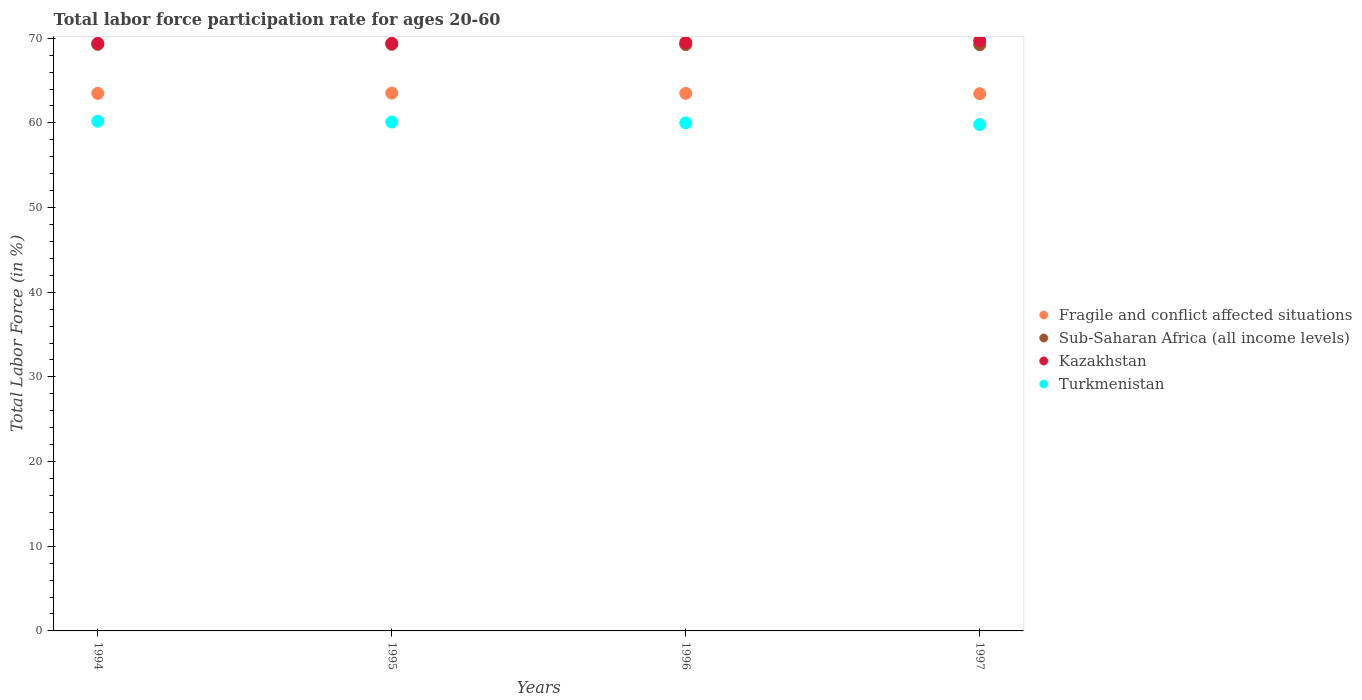How many different coloured dotlines are there?
Your answer should be very brief. 4. What is the labor force participation rate in Sub-Saharan Africa (all income levels) in 1995?
Offer a terse response. 69.28. Across all years, what is the maximum labor force participation rate in Sub-Saharan Africa (all income levels)?
Offer a terse response. 69.28. Across all years, what is the minimum labor force participation rate in Kazakhstan?
Offer a very short reply. 69.4. In which year was the labor force participation rate in Kazakhstan minimum?
Ensure brevity in your answer.  1994. What is the total labor force participation rate in Turkmenistan in the graph?
Your response must be concise. 240.1. What is the difference between the labor force participation rate in Sub-Saharan Africa (all income levels) in 1994 and that in 1997?
Ensure brevity in your answer.  0.04. What is the difference between the labor force participation rate in Fragile and conflict affected situations in 1994 and the labor force participation rate in Turkmenistan in 1997?
Keep it short and to the point. 3.69. What is the average labor force participation rate in Turkmenistan per year?
Make the answer very short. 60.02. In the year 1997, what is the difference between the labor force participation rate in Turkmenistan and labor force participation rate in Sub-Saharan Africa (all income levels)?
Your answer should be very brief. -9.43. Is the labor force participation rate in Turkmenistan in 1994 less than that in 1996?
Keep it short and to the point. No. Is the difference between the labor force participation rate in Turkmenistan in 1994 and 1996 greater than the difference between the labor force participation rate in Sub-Saharan Africa (all income levels) in 1994 and 1996?
Your response must be concise. Yes. What is the difference between the highest and the second highest labor force participation rate in Turkmenistan?
Your answer should be very brief. 0.1. What is the difference between the highest and the lowest labor force participation rate in Sub-Saharan Africa (all income levels)?
Your answer should be compact. 0.04. In how many years, is the labor force participation rate in Fragile and conflict affected situations greater than the average labor force participation rate in Fragile and conflict affected situations taken over all years?
Your answer should be compact. 3. Is the sum of the labor force participation rate in Sub-Saharan Africa (all income levels) in 1994 and 1996 greater than the maximum labor force participation rate in Fragile and conflict affected situations across all years?
Offer a very short reply. Yes. Is it the case that in every year, the sum of the labor force participation rate in Fragile and conflict affected situations and labor force participation rate in Sub-Saharan Africa (all income levels)  is greater than the labor force participation rate in Turkmenistan?
Your answer should be very brief. Yes. Does the labor force participation rate in Sub-Saharan Africa (all income levels) monotonically increase over the years?
Offer a very short reply. No. How many dotlines are there?
Provide a succinct answer. 4. Are the values on the major ticks of Y-axis written in scientific E-notation?
Provide a succinct answer. No. Does the graph contain any zero values?
Make the answer very short. No. Does the graph contain grids?
Provide a short and direct response. No. How many legend labels are there?
Make the answer very short. 4. What is the title of the graph?
Give a very brief answer. Total labor force participation rate for ages 20-60. What is the label or title of the X-axis?
Keep it short and to the point. Years. What is the Total Labor Force (in %) in Fragile and conflict affected situations in 1994?
Make the answer very short. 63.49. What is the Total Labor Force (in %) of Sub-Saharan Africa (all income levels) in 1994?
Give a very brief answer. 69.27. What is the Total Labor Force (in %) in Kazakhstan in 1994?
Offer a very short reply. 69.4. What is the Total Labor Force (in %) of Turkmenistan in 1994?
Provide a succinct answer. 60.2. What is the Total Labor Force (in %) in Fragile and conflict affected situations in 1995?
Give a very brief answer. 63.52. What is the Total Labor Force (in %) in Sub-Saharan Africa (all income levels) in 1995?
Provide a succinct answer. 69.28. What is the Total Labor Force (in %) in Kazakhstan in 1995?
Keep it short and to the point. 69.4. What is the Total Labor Force (in %) in Turkmenistan in 1995?
Make the answer very short. 60.1. What is the Total Labor Force (in %) in Fragile and conflict affected situations in 1996?
Your response must be concise. 63.49. What is the Total Labor Force (in %) in Sub-Saharan Africa (all income levels) in 1996?
Your answer should be very brief. 69.25. What is the Total Labor Force (in %) in Kazakhstan in 1996?
Offer a very short reply. 69.5. What is the Total Labor Force (in %) of Fragile and conflict affected situations in 1997?
Ensure brevity in your answer.  63.45. What is the Total Labor Force (in %) of Sub-Saharan Africa (all income levels) in 1997?
Offer a terse response. 69.23. What is the Total Labor Force (in %) of Kazakhstan in 1997?
Make the answer very short. 69.7. What is the Total Labor Force (in %) of Turkmenistan in 1997?
Provide a succinct answer. 59.8. Across all years, what is the maximum Total Labor Force (in %) of Fragile and conflict affected situations?
Your answer should be very brief. 63.52. Across all years, what is the maximum Total Labor Force (in %) of Sub-Saharan Africa (all income levels)?
Your answer should be compact. 69.28. Across all years, what is the maximum Total Labor Force (in %) of Kazakhstan?
Ensure brevity in your answer.  69.7. Across all years, what is the maximum Total Labor Force (in %) of Turkmenistan?
Make the answer very short. 60.2. Across all years, what is the minimum Total Labor Force (in %) in Fragile and conflict affected situations?
Ensure brevity in your answer.  63.45. Across all years, what is the minimum Total Labor Force (in %) in Sub-Saharan Africa (all income levels)?
Provide a short and direct response. 69.23. Across all years, what is the minimum Total Labor Force (in %) of Kazakhstan?
Your response must be concise. 69.4. Across all years, what is the minimum Total Labor Force (in %) in Turkmenistan?
Offer a terse response. 59.8. What is the total Total Labor Force (in %) in Fragile and conflict affected situations in the graph?
Your response must be concise. 253.95. What is the total Total Labor Force (in %) of Sub-Saharan Africa (all income levels) in the graph?
Offer a very short reply. 277.03. What is the total Total Labor Force (in %) of Kazakhstan in the graph?
Your answer should be compact. 278. What is the total Total Labor Force (in %) in Turkmenistan in the graph?
Offer a terse response. 240.1. What is the difference between the Total Labor Force (in %) of Fragile and conflict affected situations in 1994 and that in 1995?
Give a very brief answer. -0.03. What is the difference between the Total Labor Force (in %) of Sub-Saharan Africa (all income levels) in 1994 and that in 1995?
Keep it short and to the point. -0.01. What is the difference between the Total Labor Force (in %) in Fragile and conflict affected situations in 1994 and that in 1996?
Keep it short and to the point. -0. What is the difference between the Total Labor Force (in %) of Sub-Saharan Africa (all income levels) in 1994 and that in 1996?
Your response must be concise. 0.02. What is the difference between the Total Labor Force (in %) of Kazakhstan in 1994 and that in 1996?
Ensure brevity in your answer.  -0.1. What is the difference between the Total Labor Force (in %) of Turkmenistan in 1994 and that in 1996?
Your answer should be compact. 0.2. What is the difference between the Total Labor Force (in %) of Fragile and conflict affected situations in 1994 and that in 1997?
Offer a terse response. 0.04. What is the difference between the Total Labor Force (in %) in Sub-Saharan Africa (all income levels) in 1994 and that in 1997?
Make the answer very short. 0.04. What is the difference between the Total Labor Force (in %) of Kazakhstan in 1994 and that in 1997?
Make the answer very short. -0.3. What is the difference between the Total Labor Force (in %) in Fragile and conflict affected situations in 1995 and that in 1996?
Give a very brief answer. 0.03. What is the difference between the Total Labor Force (in %) in Sub-Saharan Africa (all income levels) in 1995 and that in 1996?
Offer a very short reply. 0.03. What is the difference between the Total Labor Force (in %) of Turkmenistan in 1995 and that in 1996?
Make the answer very short. 0.1. What is the difference between the Total Labor Force (in %) of Fragile and conflict affected situations in 1995 and that in 1997?
Make the answer very short. 0.07. What is the difference between the Total Labor Force (in %) of Sub-Saharan Africa (all income levels) in 1995 and that in 1997?
Your answer should be very brief. 0.04. What is the difference between the Total Labor Force (in %) of Fragile and conflict affected situations in 1996 and that in 1997?
Your answer should be very brief. 0.04. What is the difference between the Total Labor Force (in %) in Sub-Saharan Africa (all income levels) in 1996 and that in 1997?
Ensure brevity in your answer.  0.01. What is the difference between the Total Labor Force (in %) of Kazakhstan in 1996 and that in 1997?
Give a very brief answer. -0.2. What is the difference between the Total Labor Force (in %) in Turkmenistan in 1996 and that in 1997?
Offer a terse response. 0.2. What is the difference between the Total Labor Force (in %) of Fragile and conflict affected situations in 1994 and the Total Labor Force (in %) of Sub-Saharan Africa (all income levels) in 1995?
Offer a terse response. -5.79. What is the difference between the Total Labor Force (in %) in Fragile and conflict affected situations in 1994 and the Total Labor Force (in %) in Kazakhstan in 1995?
Offer a terse response. -5.91. What is the difference between the Total Labor Force (in %) in Fragile and conflict affected situations in 1994 and the Total Labor Force (in %) in Turkmenistan in 1995?
Give a very brief answer. 3.39. What is the difference between the Total Labor Force (in %) of Sub-Saharan Africa (all income levels) in 1994 and the Total Labor Force (in %) of Kazakhstan in 1995?
Ensure brevity in your answer.  -0.13. What is the difference between the Total Labor Force (in %) of Sub-Saharan Africa (all income levels) in 1994 and the Total Labor Force (in %) of Turkmenistan in 1995?
Offer a terse response. 9.17. What is the difference between the Total Labor Force (in %) of Kazakhstan in 1994 and the Total Labor Force (in %) of Turkmenistan in 1995?
Make the answer very short. 9.3. What is the difference between the Total Labor Force (in %) in Fragile and conflict affected situations in 1994 and the Total Labor Force (in %) in Sub-Saharan Africa (all income levels) in 1996?
Your answer should be compact. -5.76. What is the difference between the Total Labor Force (in %) of Fragile and conflict affected situations in 1994 and the Total Labor Force (in %) of Kazakhstan in 1996?
Offer a very short reply. -6.01. What is the difference between the Total Labor Force (in %) in Fragile and conflict affected situations in 1994 and the Total Labor Force (in %) in Turkmenistan in 1996?
Your answer should be very brief. 3.49. What is the difference between the Total Labor Force (in %) of Sub-Saharan Africa (all income levels) in 1994 and the Total Labor Force (in %) of Kazakhstan in 1996?
Your answer should be very brief. -0.23. What is the difference between the Total Labor Force (in %) in Sub-Saharan Africa (all income levels) in 1994 and the Total Labor Force (in %) in Turkmenistan in 1996?
Make the answer very short. 9.27. What is the difference between the Total Labor Force (in %) of Kazakhstan in 1994 and the Total Labor Force (in %) of Turkmenistan in 1996?
Keep it short and to the point. 9.4. What is the difference between the Total Labor Force (in %) in Fragile and conflict affected situations in 1994 and the Total Labor Force (in %) in Sub-Saharan Africa (all income levels) in 1997?
Provide a short and direct response. -5.75. What is the difference between the Total Labor Force (in %) in Fragile and conflict affected situations in 1994 and the Total Labor Force (in %) in Kazakhstan in 1997?
Offer a terse response. -6.21. What is the difference between the Total Labor Force (in %) of Fragile and conflict affected situations in 1994 and the Total Labor Force (in %) of Turkmenistan in 1997?
Give a very brief answer. 3.69. What is the difference between the Total Labor Force (in %) in Sub-Saharan Africa (all income levels) in 1994 and the Total Labor Force (in %) in Kazakhstan in 1997?
Your answer should be compact. -0.43. What is the difference between the Total Labor Force (in %) of Sub-Saharan Africa (all income levels) in 1994 and the Total Labor Force (in %) of Turkmenistan in 1997?
Make the answer very short. 9.47. What is the difference between the Total Labor Force (in %) in Kazakhstan in 1994 and the Total Labor Force (in %) in Turkmenistan in 1997?
Ensure brevity in your answer.  9.6. What is the difference between the Total Labor Force (in %) in Fragile and conflict affected situations in 1995 and the Total Labor Force (in %) in Sub-Saharan Africa (all income levels) in 1996?
Keep it short and to the point. -5.73. What is the difference between the Total Labor Force (in %) in Fragile and conflict affected situations in 1995 and the Total Labor Force (in %) in Kazakhstan in 1996?
Your answer should be very brief. -5.98. What is the difference between the Total Labor Force (in %) of Fragile and conflict affected situations in 1995 and the Total Labor Force (in %) of Turkmenistan in 1996?
Provide a succinct answer. 3.52. What is the difference between the Total Labor Force (in %) of Sub-Saharan Africa (all income levels) in 1995 and the Total Labor Force (in %) of Kazakhstan in 1996?
Provide a short and direct response. -0.22. What is the difference between the Total Labor Force (in %) in Sub-Saharan Africa (all income levels) in 1995 and the Total Labor Force (in %) in Turkmenistan in 1996?
Make the answer very short. 9.28. What is the difference between the Total Labor Force (in %) of Kazakhstan in 1995 and the Total Labor Force (in %) of Turkmenistan in 1996?
Your answer should be compact. 9.4. What is the difference between the Total Labor Force (in %) in Fragile and conflict affected situations in 1995 and the Total Labor Force (in %) in Sub-Saharan Africa (all income levels) in 1997?
Provide a succinct answer. -5.71. What is the difference between the Total Labor Force (in %) of Fragile and conflict affected situations in 1995 and the Total Labor Force (in %) of Kazakhstan in 1997?
Provide a succinct answer. -6.18. What is the difference between the Total Labor Force (in %) in Fragile and conflict affected situations in 1995 and the Total Labor Force (in %) in Turkmenistan in 1997?
Give a very brief answer. 3.72. What is the difference between the Total Labor Force (in %) in Sub-Saharan Africa (all income levels) in 1995 and the Total Labor Force (in %) in Kazakhstan in 1997?
Keep it short and to the point. -0.42. What is the difference between the Total Labor Force (in %) of Sub-Saharan Africa (all income levels) in 1995 and the Total Labor Force (in %) of Turkmenistan in 1997?
Make the answer very short. 9.48. What is the difference between the Total Labor Force (in %) in Fragile and conflict affected situations in 1996 and the Total Labor Force (in %) in Sub-Saharan Africa (all income levels) in 1997?
Ensure brevity in your answer.  -5.74. What is the difference between the Total Labor Force (in %) of Fragile and conflict affected situations in 1996 and the Total Labor Force (in %) of Kazakhstan in 1997?
Offer a very short reply. -6.21. What is the difference between the Total Labor Force (in %) of Fragile and conflict affected situations in 1996 and the Total Labor Force (in %) of Turkmenistan in 1997?
Provide a succinct answer. 3.69. What is the difference between the Total Labor Force (in %) in Sub-Saharan Africa (all income levels) in 1996 and the Total Labor Force (in %) in Kazakhstan in 1997?
Your answer should be very brief. -0.45. What is the difference between the Total Labor Force (in %) of Sub-Saharan Africa (all income levels) in 1996 and the Total Labor Force (in %) of Turkmenistan in 1997?
Your answer should be compact. 9.45. What is the average Total Labor Force (in %) in Fragile and conflict affected situations per year?
Give a very brief answer. 63.49. What is the average Total Labor Force (in %) of Sub-Saharan Africa (all income levels) per year?
Your response must be concise. 69.26. What is the average Total Labor Force (in %) of Kazakhstan per year?
Make the answer very short. 69.5. What is the average Total Labor Force (in %) in Turkmenistan per year?
Offer a terse response. 60.02. In the year 1994, what is the difference between the Total Labor Force (in %) in Fragile and conflict affected situations and Total Labor Force (in %) in Sub-Saharan Africa (all income levels)?
Ensure brevity in your answer.  -5.78. In the year 1994, what is the difference between the Total Labor Force (in %) in Fragile and conflict affected situations and Total Labor Force (in %) in Kazakhstan?
Your response must be concise. -5.91. In the year 1994, what is the difference between the Total Labor Force (in %) in Fragile and conflict affected situations and Total Labor Force (in %) in Turkmenistan?
Keep it short and to the point. 3.29. In the year 1994, what is the difference between the Total Labor Force (in %) in Sub-Saharan Africa (all income levels) and Total Labor Force (in %) in Kazakhstan?
Your answer should be compact. -0.13. In the year 1994, what is the difference between the Total Labor Force (in %) in Sub-Saharan Africa (all income levels) and Total Labor Force (in %) in Turkmenistan?
Provide a short and direct response. 9.07. In the year 1994, what is the difference between the Total Labor Force (in %) of Kazakhstan and Total Labor Force (in %) of Turkmenistan?
Ensure brevity in your answer.  9.2. In the year 1995, what is the difference between the Total Labor Force (in %) in Fragile and conflict affected situations and Total Labor Force (in %) in Sub-Saharan Africa (all income levels)?
Your answer should be very brief. -5.76. In the year 1995, what is the difference between the Total Labor Force (in %) in Fragile and conflict affected situations and Total Labor Force (in %) in Kazakhstan?
Make the answer very short. -5.88. In the year 1995, what is the difference between the Total Labor Force (in %) in Fragile and conflict affected situations and Total Labor Force (in %) in Turkmenistan?
Ensure brevity in your answer.  3.42. In the year 1995, what is the difference between the Total Labor Force (in %) of Sub-Saharan Africa (all income levels) and Total Labor Force (in %) of Kazakhstan?
Make the answer very short. -0.12. In the year 1995, what is the difference between the Total Labor Force (in %) in Sub-Saharan Africa (all income levels) and Total Labor Force (in %) in Turkmenistan?
Give a very brief answer. 9.18. In the year 1996, what is the difference between the Total Labor Force (in %) in Fragile and conflict affected situations and Total Labor Force (in %) in Sub-Saharan Africa (all income levels)?
Your answer should be compact. -5.76. In the year 1996, what is the difference between the Total Labor Force (in %) of Fragile and conflict affected situations and Total Labor Force (in %) of Kazakhstan?
Provide a short and direct response. -6.01. In the year 1996, what is the difference between the Total Labor Force (in %) of Fragile and conflict affected situations and Total Labor Force (in %) of Turkmenistan?
Provide a succinct answer. 3.49. In the year 1996, what is the difference between the Total Labor Force (in %) of Sub-Saharan Africa (all income levels) and Total Labor Force (in %) of Kazakhstan?
Make the answer very short. -0.25. In the year 1996, what is the difference between the Total Labor Force (in %) in Sub-Saharan Africa (all income levels) and Total Labor Force (in %) in Turkmenistan?
Your response must be concise. 9.25. In the year 1997, what is the difference between the Total Labor Force (in %) in Fragile and conflict affected situations and Total Labor Force (in %) in Sub-Saharan Africa (all income levels)?
Give a very brief answer. -5.79. In the year 1997, what is the difference between the Total Labor Force (in %) in Fragile and conflict affected situations and Total Labor Force (in %) in Kazakhstan?
Offer a terse response. -6.25. In the year 1997, what is the difference between the Total Labor Force (in %) of Fragile and conflict affected situations and Total Labor Force (in %) of Turkmenistan?
Your answer should be very brief. 3.65. In the year 1997, what is the difference between the Total Labor Force (in %) in Sub-Saharan Africa (all income levels) and Total Labor Force (in %) in Kazakhstan?
Keep it short and to the point. -0.47. In the year 1997, what is the difference between the Total Labor Force (in %) of Sub-Saharan Africa (all income levels) and Total Labor Force (in %) of Turkmenistan?
Keep it short and to the point. 9.43. In the year 1997, what is the difference between the Total Labor Force (in %) of Kazakhstan and Total Labor Force (in %) of Turkmenistan?
Provide a succinct answer. 9.9. What is the ratio of the Total Labor Force (in %) of Fragile and conflict affected situations in 1994 to that in 1995?
Ensure brevity in your answer.  1. What is the ratio of the Total Labor Force (in %) of Kazakhstan in 1994 to that in 1995?
Offer a terse response. 1. What is the ratio of the Total Labor Force (in %) in Turkmenistan in 1994 to that in 1995?
Offer a very short reply. 1. What is the ratio of the Total Labor Force (in %) of Fragile and conflict affected situations in 1994 to that in 1996?
Keep it short and to the point. 1. What is the ratio of the Total Labor Force (in %) in Fragile and conflict affected situations in 1994 to that in 1997?
Make the answer very short. 1. What is the ratio of the Total Labor Force (in %) in Turkmenistan in 1994 to that in 1997?
Provide a short and direct response. 1.01. What is the ratio of the Total Labor Force (in %) of Fragile and conflict affected situations in 1995 to that in 1996?
Provide a succinct answer. 1. What is the ratio of the Total Labor Force (in %) in Sub-Saharan Africa (all income levels) in 1995 to that in 1996?
Provide a succinct answer. 1. What is the ratio of the Total Labor Force (in %) of Sub-Saharan Africa (all income levels) in 1995 to that in 1997?
Your response must be concise. 1. What is the ratio of the Total Labor Force (in %) in Kazakhstan in 1995 to that in 1997?
Offer a very short reply. 1. What is the ratio of the Total Labor Force (in %) of Turkmenistan in 1995 to that in 1997?
Your answer should be very brief. 1. What is the ratio of the Total Labor Force (in %) in Fragile and conflict affected situations in 1996 to that in 1997?
Your answer should be compact. 1. What is the ratio of the Total Labor Force (in %) of Sub-Saharan Africa (all income levels) in 1996 to that in 1997?
Your answer should be compact. 1. What is the ratio of the Total Labor Force (in %) of Turkmenistan in 1996 to that in 1997?
Ensure brevity in your answer.  1. What is the difference between the highest and the second highest Total Labor Force (in %) in Fragile and conflict affected situations?
Keep it short and to the point. 0.03. What is the difference between the highest and the second highest Total Labor Force (in %) of Sub-Saharan Africa (all income levels)?
Give a very brief answer. 0.01. What is the difference between the highest and the second highest Total Labor Force (in %) in Kazakhstan?
Offer a very short reply. 0.2. What is the difference between the highest and the second highest Total Labor Force (in %) of Turkmenistan?
Keep it short and to the point. 0.1. What is the difference between the highest and the lowest Total Labor Force (in %) in Fragile and conflict affected situations?
Offer a terse response. 0.07. What is the difference between the highest and the lowest Total Labor Force (in %) of Sub-Saharan Africa (all income levels)?
Your answer should be compact. 0.04. What is the difference between the highest and the lowest Total Labor Force (in %) in Turkmenistan?
Keep it short and to the point. 0.4. 